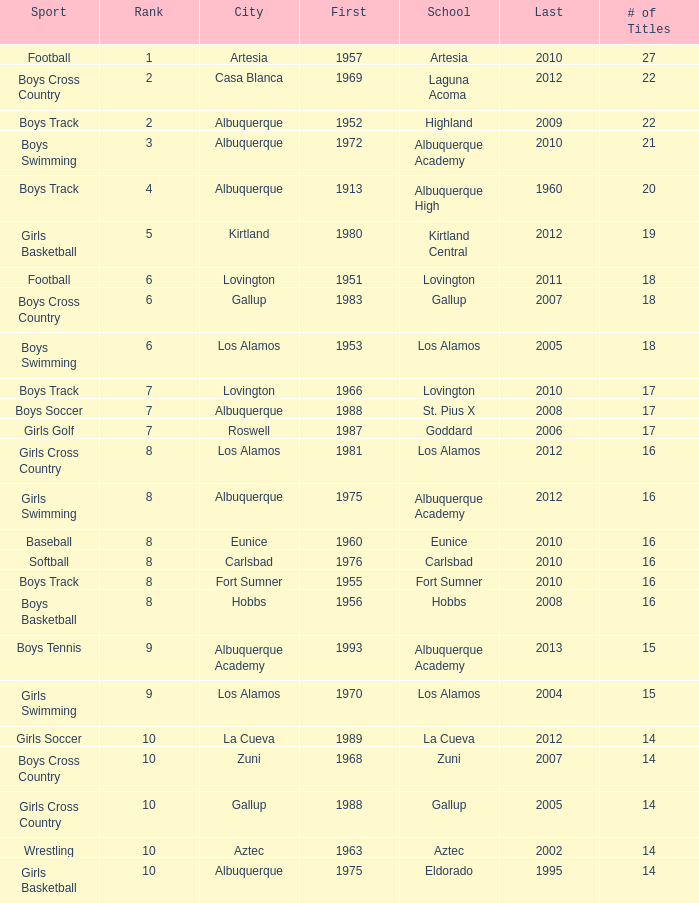What city is the school that had less than 17 titles in boys basketball with the last title being after 2005? Hobbs. 